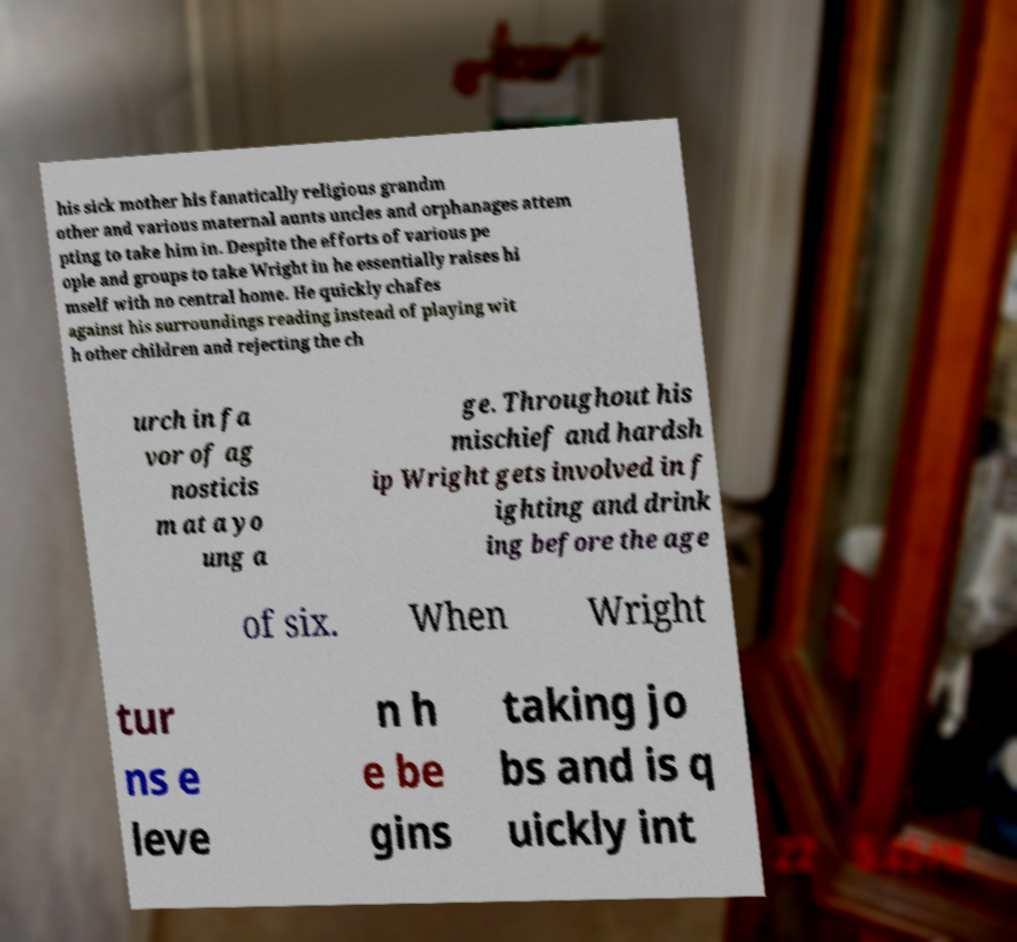Can you accurately transcribe the text from the provided image for me? his sick mother his fanatically religious grandm other and various maternal aunts uncles and orphanages attem pting to take him in. Despite the efforts of various pe ople and groups to take Wright in he essentially raises hi mself with no central home. He quickly chafes against his surroundings reading instead of playing wit h other children and rejecting the ch urch in fa vor of ag nosticis m at a yo ung a ge. Throughout his mischief and hardsh ip Wright gets involved in f ighting and drink ing before the age of six. When Wright tur ns e leve n h e be gins taking jo bs and is q uickly int 